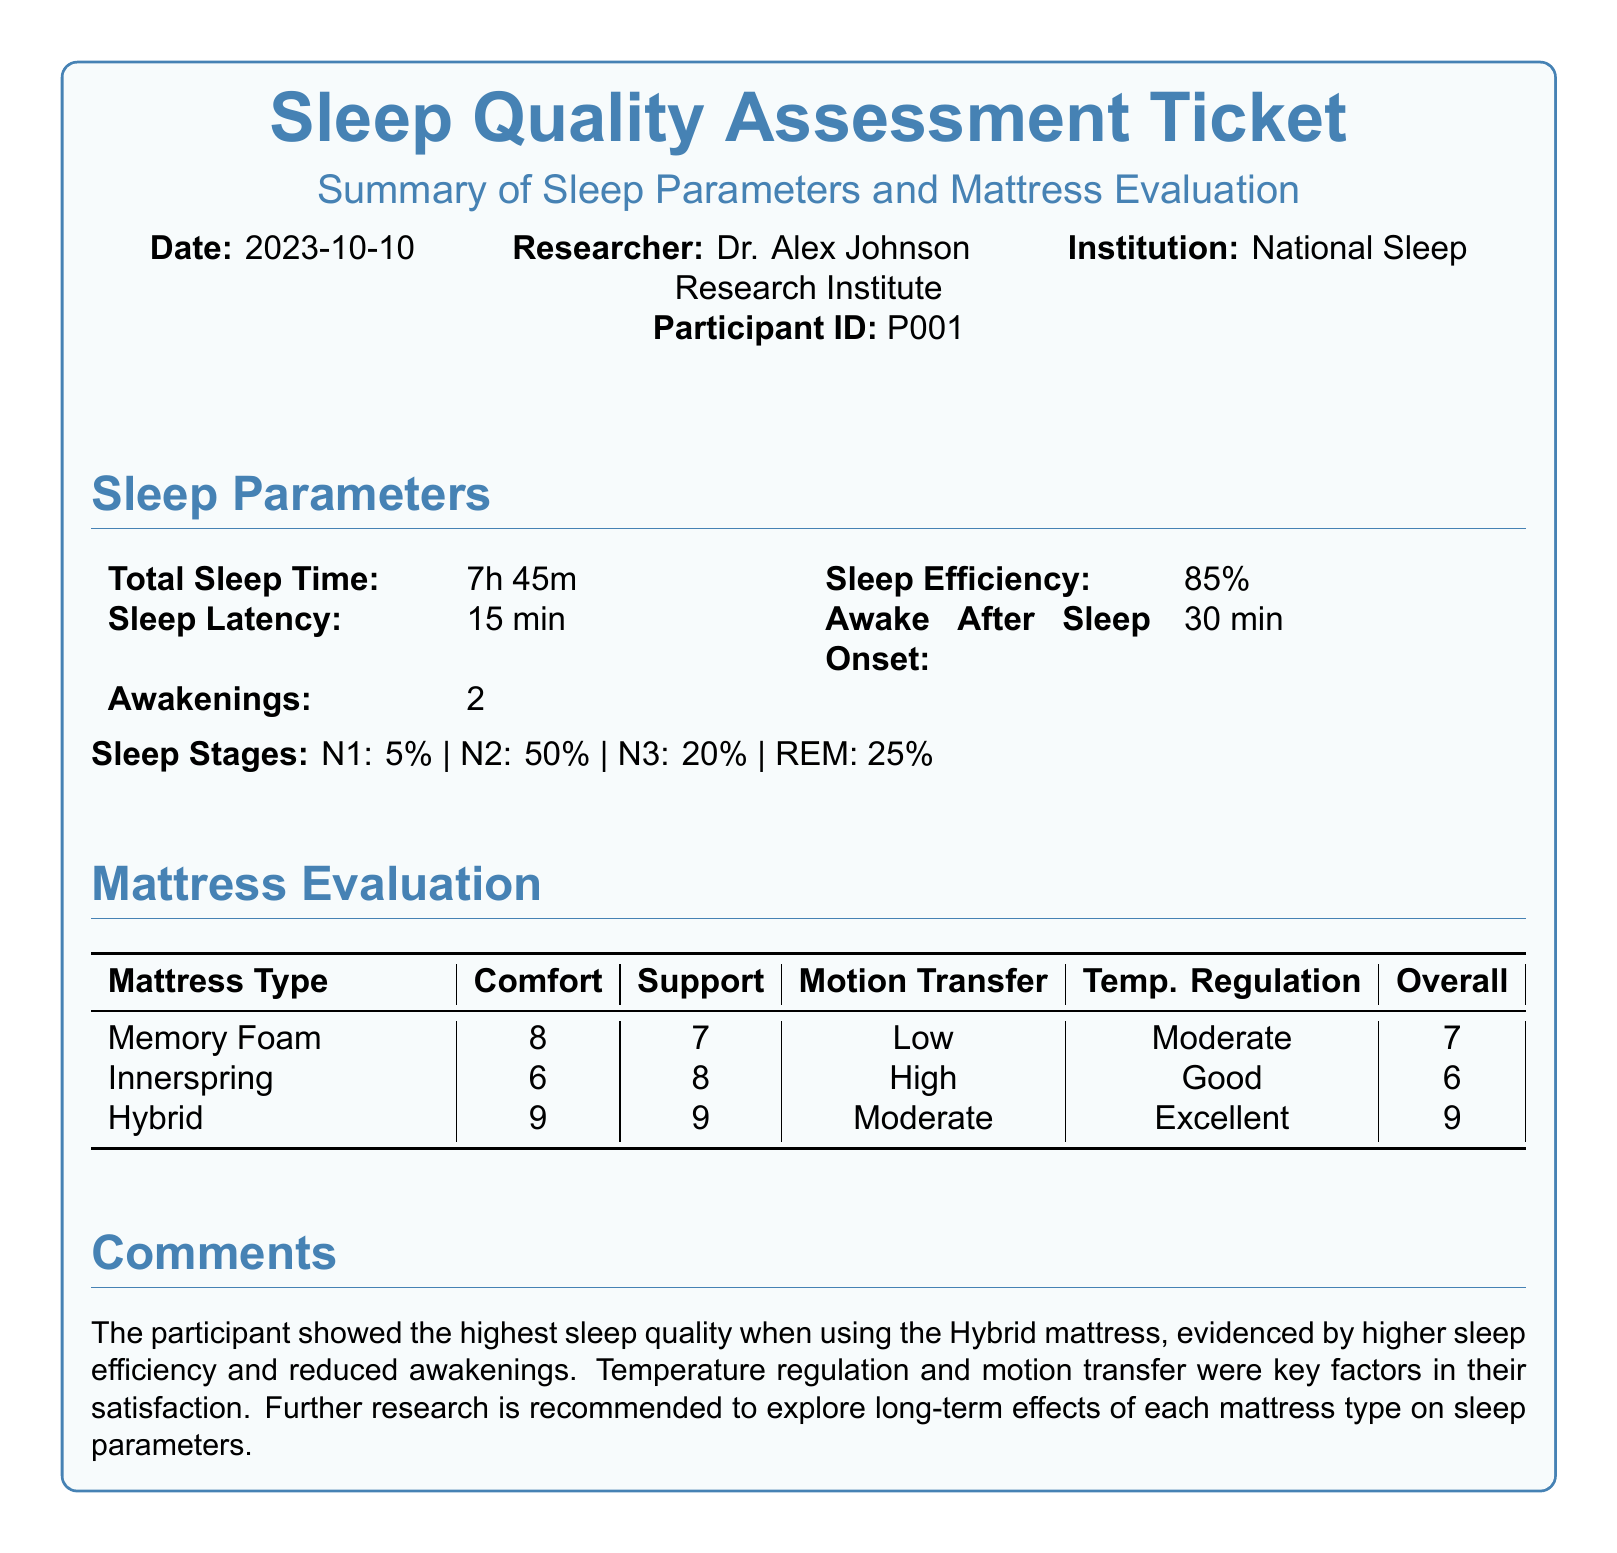what is the total sleep time? The total sleep time is listed in the sleep parameters section of the document as 7 hours and 45 minutes.
Answer: 7h 45m what is the sleep efficiency percentage? The sleep efficiency is specifically mentioned in the sleep parameters section as a percentage.
Answer: 85% how many awakenings did the participant have? The number of awakenings is provided in the sleep parameters table, indicating the count.
Answer: 2 which mattress type had the highest overall score? The overall scores for each mattress type are compared, and the highest score is noted.
Answer: Hybrid what was the comfort rating for the Memory Foam mattress? The comfort rating is specified in the mattress evaluation table next to the Memory Foam entry.
Answer: 8 what is the sleep latency reported in the document? The sleep latency is included in the sleep parameters section and is specifically noted.
Answer: 15 min which mattress type had the best temperature regulation? The mattress evaluation table indicates the level of temperature regulation for each type.
Answer: Hybrid who is the researcher conducting this study? The researcher’s name is provided at the top of the document in the header information.
Answer: Dr. Alex Johnson what date was this assessment made? The date of the assessment is clearly stated in the document header.
Answer: 2023-10-10 